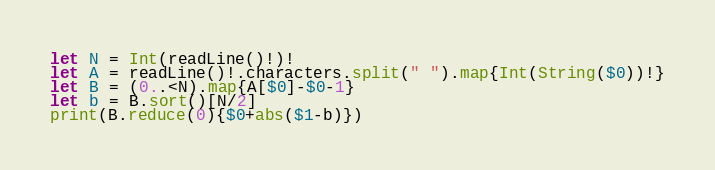Convert code to text. <code><loc_0><loc_0><loc_500><loc_500><_Swift_>let N = Int(readLine()!)!
let A = readLine()!.characters.split(" ").map{Int(String($0))!}
let B = (0..<N).map{A[$0]-$0-1}
let b = B.sort()[N/2]
print(B.reduce(0){$0+abs($1-b)})</code> 